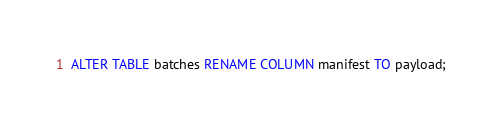<code> <loc_0><loc_0><loc_500><loc_500><_SQL_>ALTER TABLE batches RENAME COLUMN manifest TO payload;
</code> 